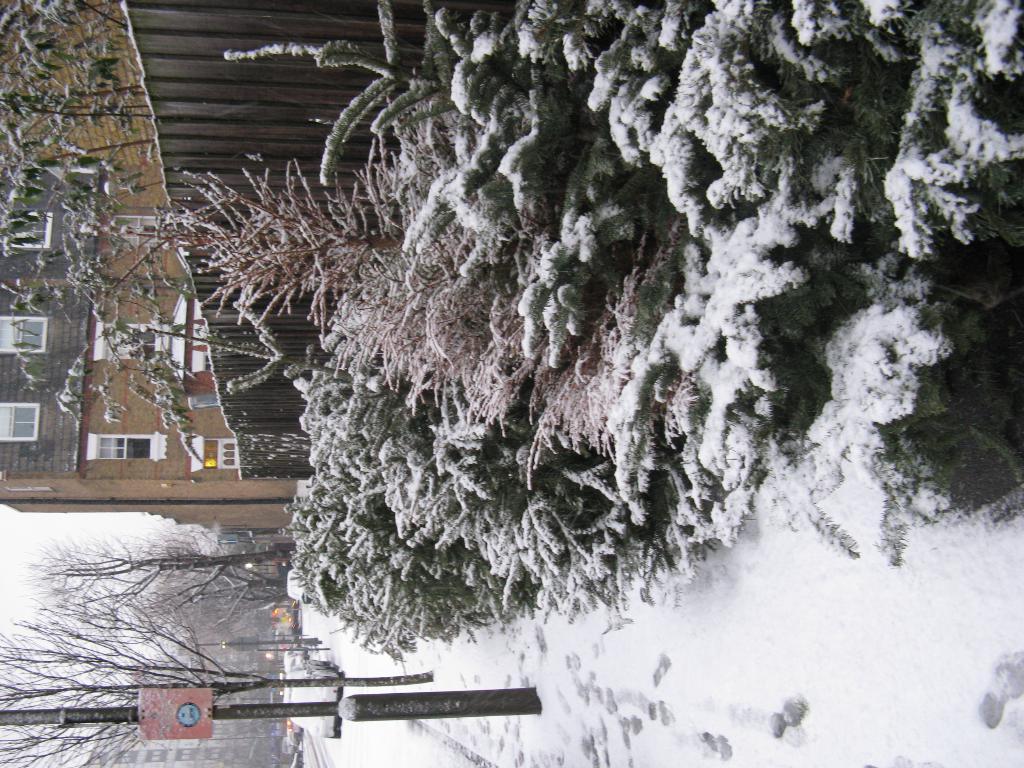Can you describe this image briefly? This image is taken outdoor. At the bottom of the image there is a road covered with snow. At the top right of the image there are a few plants and there is a tree covered with snow. At the top left of the image there is a building with walls, windows and there is a wooden fence. At the left bottom of the image there are a few trees. There is a signboard. There are a few buildings and a few cars are moving on the road. 